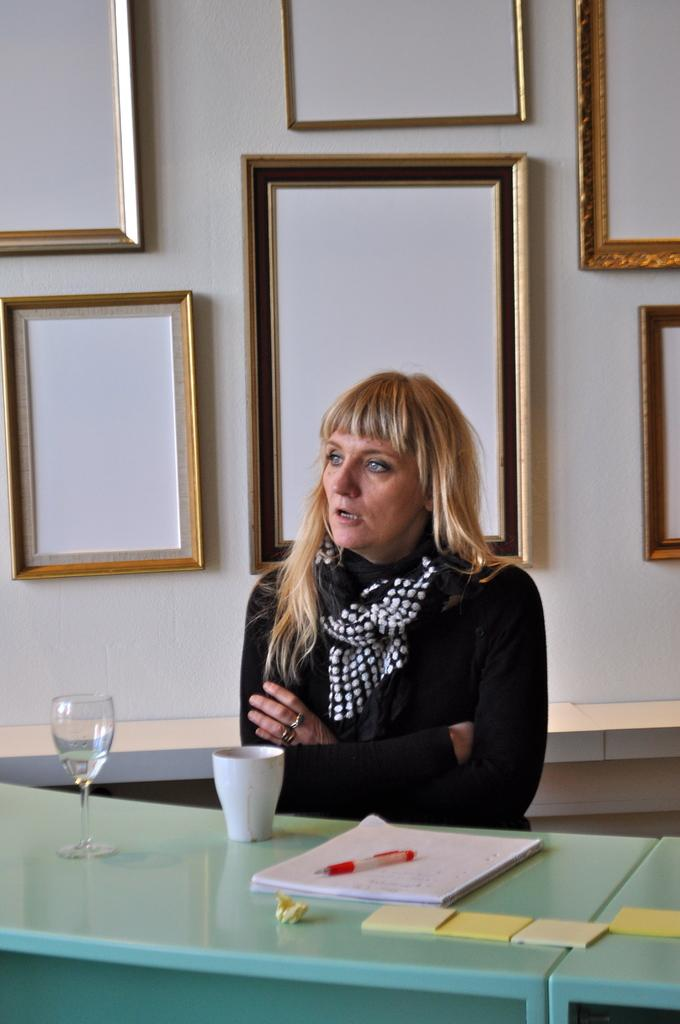What is the main setting of the image? There is a room in the image. What is the person in the room doing? The person is sitting on a chair in the room. What is the person wearing that is visible in the image? The person is wearing a scarf. What furniture is present in the room? There is a table in the room. What items can be seen on the table? There is a glass, a cup, a paper, and a pen on the table. What is hanging on the wall in the background? There is a photo frame on the wall in the background. What is visible behind the photo frame? There is a wall visible in the background. How many brothers are visible in the image? There are no brothers present in the image. What type of bear can be seen interacting with the person in the image? There is no bear present in the image. Is the chicken on the table in the image? There is no chicken present in the image. 